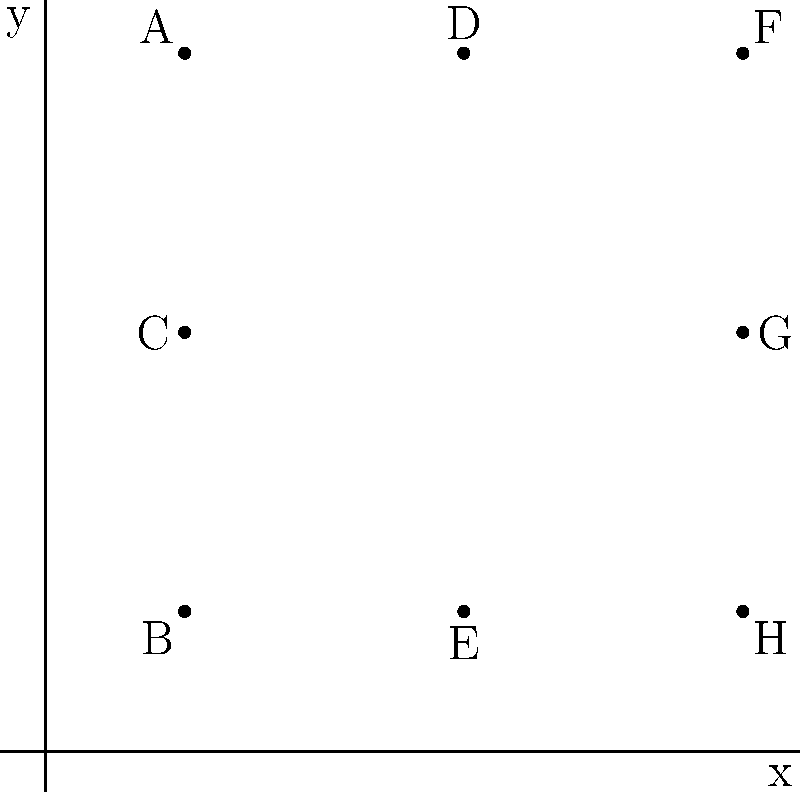As Theodore's childhood friend, you want to create a special design using his initials "TD" on a Cartesian plane. Given the points A(1,5), B(1,1), C(1,3), D(3,5), E(3,1), F(5,5), G(5,3), and H(5,1), which sequence of points would you connect to form Theodore's initials "TD"? To form Theodore's initials "TD" on the Cartesian plane, we need to connect the points in a specific order:

1. For the letter "T":
   - Start at point A(1,5)
   - Connect to point F(5,5) to form the top of the T
   - Then connect to point G(5,3) to form the vertical line of the T

2. For the letter "D":
   - Move to point B(1,1) without drawing a line
   - Connect to point C(1,3) to start the left side of the D
   - Continue to point D(3,5) to form the top curve of the D
   - Connect to point F(5,5) to complete the top of the D
   - Then to point H(5,1) to form the right side of the D
   - Finally, connect back to point B(1,1) to close the D

The sequence that forms "TD" is: A → F → G, then B → C → D → F → H → B
Answer: A, F, G, B, C, D, F, H, B 